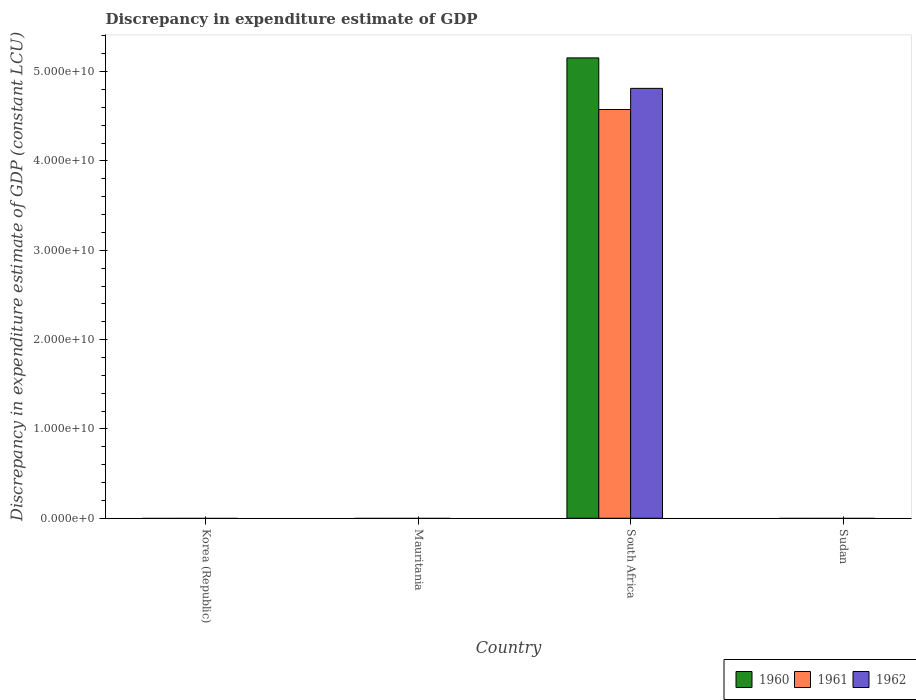How many different coloured bars are there?
Offer a very short reply. 3. What is the label of the 1st group of bars from the left?
Provide a short and direct response. Korea (Republic). What is the discrepancy in expenditure estimate of GDP in 1960 in Mauritania?
Offer a terse response. 0. Across all countries, what is the maximum discrepancy in expenditure estimate of GDP in 1962?
Give a very brief answer. 4.81e+1. In which country was the discrepancy in expenditure estimate of GDP in 1962 maximum?
Your answer should be compact. South Africa. What is the total discrepancy in expenditure estimate of GDP in 1960 in the graph?
Your response must be concise. 5.15e+1. What is the average discrepancy in expenditure estimate of GDP in 1961 per country?
Keep it short and to the point. 1.14e+1. What is the difference between the discrepancy in expenditure estimate of GDP of/in 1961 and discrepancy in expenditure estimate of GDP of/in 1960 in South Africa?
Offer a very short reply. -5.78e+09. What is the difference between the highest and the lowest discrepancy in expenditure estimate of GDP in 1961?
Give a very brief answer. 4.58e+1. In how many countries, is the discrepancy in expenditure estimate of GDP in 1962 greater than the average discrepancy in expenditure estimate of GDP in 1962 taken over all countries?
Make the answer very short. 1. How many bars are there?
Keep it short and to the point. 3. Does the graph contain grids?
Your answer should be compact. No. Where does the legend appear in the graph?
Offer a very short reply. Bottom right. What is the title of the graph?
Offer a very short reply. Discrepancy in expenditure estimate of GDP. Does "1984" appear as one of the legend labels in the graph?
Your answer should be compact. No. What is the label or title of the X-axis?
Ensure brevity in your answer.  Country. What is the label or title of the Y-axis?
Your answer should be very brief. Discrepancy in expenditure estimate of GDP (constant LCU). What is the Discrepancy in expenditure estimate of GDP (constant LCU) in 1962 in Korea (Republic)?
Make the answer very short. 0. What is the Discrepancy in expenditure estimate of GDP (constant LCU) in 1960 in South Africa?
Provide a succinct answer. 5.15e+1. What is the Discrepancy in expenditure estimate of GDP (constant LCU) in 1961 in South Africa?
Provide a short and direct response. 4.58e+1. What is the Discrepancy in expenditure estimate of GDP (constant LCU) in 1962 in South Africa?
Offer a terse response. 4.81e+1. What is the Discrepancy in expenditure estimate of GDP (constant LCU) in 1961 in Sudan?
Your response must be concise. 0. What is the Discrepancy in expenditure estimate of GDP (constant LCU) of 1962 in Sudan?
Ensure brevity in your answer.  0. Across all countries, what is the maximum Discrepancy in expenditure estimate of GDP (constant LCU) of 1960?
Your answer should be very brief. 5.15e+1. Across all countries, what is the maximum Discrepancy in expenditure estimate of GDP (constant LCU) of 1961?
Provide a short and direct response. 4.58e+1. Across all countries, what is the maximum Discrepancy in expenditure estimate of GDP (constant LCU) of 1962?
Your response must be concise. 4.81e+1. What is the total Discrepancy in expenditure estimate of GDP (constant LCU) of 1960 in the graph?
Provide a short and direct response. 5.15e+1. What is the total Discrepancy in expenditure estimate of GDP (constant LCU) in 1961 in the graph?
Offer a very short reply. 4.58e+1. What is the total Discrepancy in expenditure estimate of GDP (constant LCU) of 1962 in the graph?
Offer a very short reply. 4.81e+1. What is the average Discrepancy in expenditure estimate of GDP (constant LCU) of 1960 per country?
Your answer should be compact. 1.29e+1. What is the average Discrepancy in expenditure estimate of GDP (constant LCU) in 1961 per country?
Make the answer very short. 1.14e+1. What is the average Discrepancy in expenditure estimate of GDP (constant LCU) in 1962 per country?
Offer a terse response. 1.20e+1. What is the difference between the Discrepancy in expenditure estimate of GDP (constant LCU) in 1960 and Discrepancy in expenditure estimate of GDP (constant LCU) in 1961 in South Africa?
Ensure brevity in your answer.  5.78e+09. What is the difference between the Discrepancy in expenditure estimate of GDP (constant LCU) in 1960 and Discrepancy in expenditure estimate of GDP (constant LCU) in 1962 in South Africa?
Your answer should be very brief. 3.41e+09. What is the difference between the Discrepancy in expenditure estimate of GDP (constant LCU) of 1961 and Discrepancy in expenditure estimate of GDP (constant LCU) of 1962 in South Africa?
Give a very brief answer. -2.37e+09. What is the difference between the highest and the lowest Discrepancy in expenditure estimate of GDP (constant LCU) in 1960?
Provide a short and direct response. 5.15e+1. What is the difference between the highest and the lowest Discrepancy in expenditure estimate of GDP (constant LCU) in 1961?
Offer a very short reply. 4.58e+1. What is the difference between the highest and the lowest Discrepancy in expenditure estimate of GDP (constant LCU) in 1962?
Offer a terse response. 4.81e+1. 